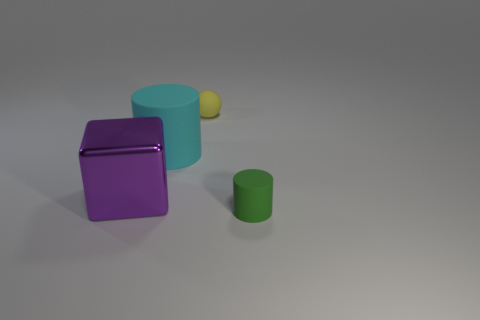Add 1 large matte cylinders. How many objects exist? 5 Subtract all balls. How many objects are left? 3 Add 4 tiny green cylinders. How many tiny green cylinders are left? 5 Add 1 cubes. How many cubes exist? 2 Subtract 0 yellow cylinders. How many objects are left? 4 Subtract all small spheres. Subtract all tiny spheres. How many objects are left? 2 